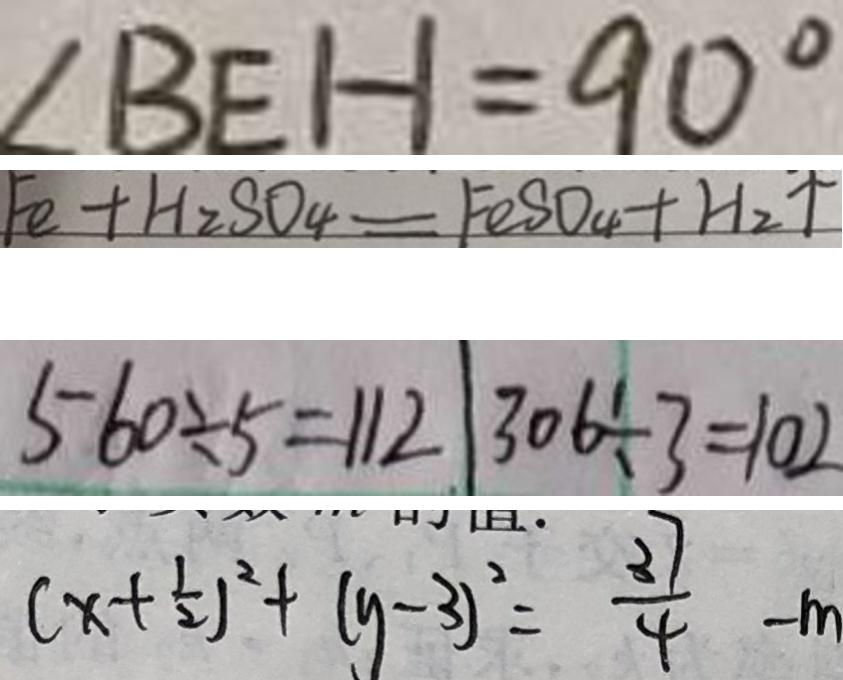Convert formula to latex. <formula><loc_0><loc_0><loc_500><loc_500>\angle B E H = 9 0 ^ { \circ } 
 F e + H _ { 2 } S O _ { 4 } = F O S O _ { 4 } + H _ { 2 } \uparrow 
 5 6 0 \div 5 = 1 1 2 3 0 6 \div 3 = 1 0 2 
 ( x + \frac { 1 } { 2 } ) ^ { 2 } + ( y - 3 ) ^ { 2 } = \frac { 3 7 } { 4 } - m</formula> 